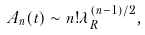<formula> <loc_0><loc_0><loc_500><loc_500>A _ { n } ( t ) \sim n ! \lambda _ { R } ^ { ( n - 1 ) / 2 } ,</formula> 